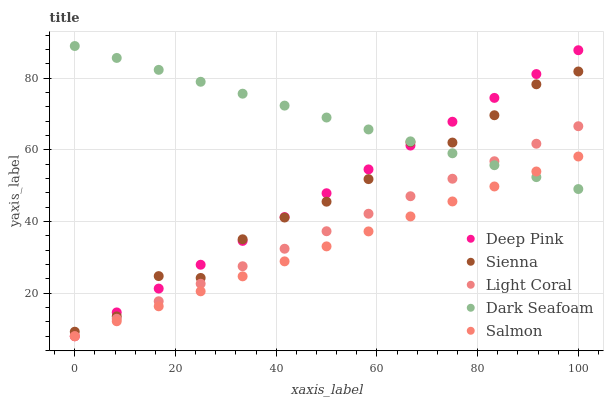Does Salmon have the minimum area under the curve?
Answer yes or no. Yes. Does Dark Seafoam have the maximum area under the curve?
Answer yes or no. Yes. Does Light Coral have the minimum area under the curve?
Answer yes or no. No. Does Light Coral have the maximum area under the curve?
Answer yes or no. No. Is Light Coral the smoothest?
Answer yes or no. Yes. Is Sienna the roughest?
Answer yes or no. Yes. Is Dark Seafoam the smoothest?
Answer yes or no. No. Is Dark Seafoam the roughest?
Answer yes or no. No. Does Light Coral have the lowest value?
Answer yes or no. Yes. Does Dark Seafoam have the lowest value?
Answer yes or no. No. Does Dark Seafoam have the highest value?
Answer yes or no. Yes. Does Light Coral have the highest value?
Answer yes or no. No. Is Light Coral less than Sienna?
Answer yes or no. Yes. Is Sienna greater than Light Coral?
Answer yes or no. Yes. Does Sienna intersect Deep Pink?
Answer yes or no. Yes. Is Sienna less than Deep Pink?
Answer yes or no. No. Is Sienna greater than Deep Pink?
Answer yes or no. No. Does Light Coral intersect Sienna?
Answer yes or no. No. 